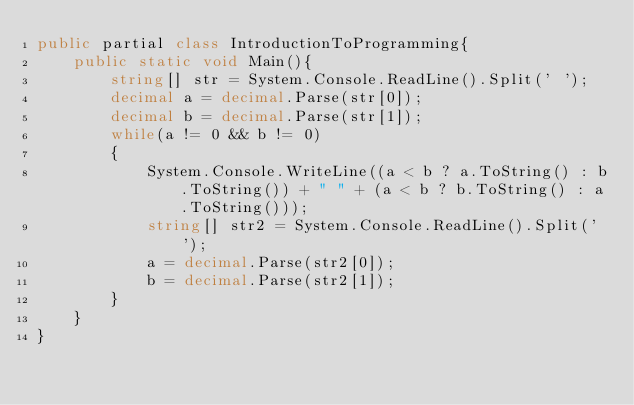<code> <loc_0><loc_0><loc_500><loc_500><_C#_>public partial class IntroductionToProgramming{
	public static void Main(){
		string[] str = System.Console.ReadLine().Split(' ');
		decimal a = decimal.Parse(str[0]);
		decimal b = decimal.Parse(str[1]);
		while(a != 0 && b != 0)
		{
			System.Console.WriteLine((a < b ? a.ToString() : b.ToString()) + " " + (a < b ? b.ToString() : a.ToString()));
			string[] str2 = System.Console.ReadLine().Split(' ');
			a = decimal.Parse(str2[0]);
			b = decimal.Parse(str2[1]);
		}
	}
}</code> 